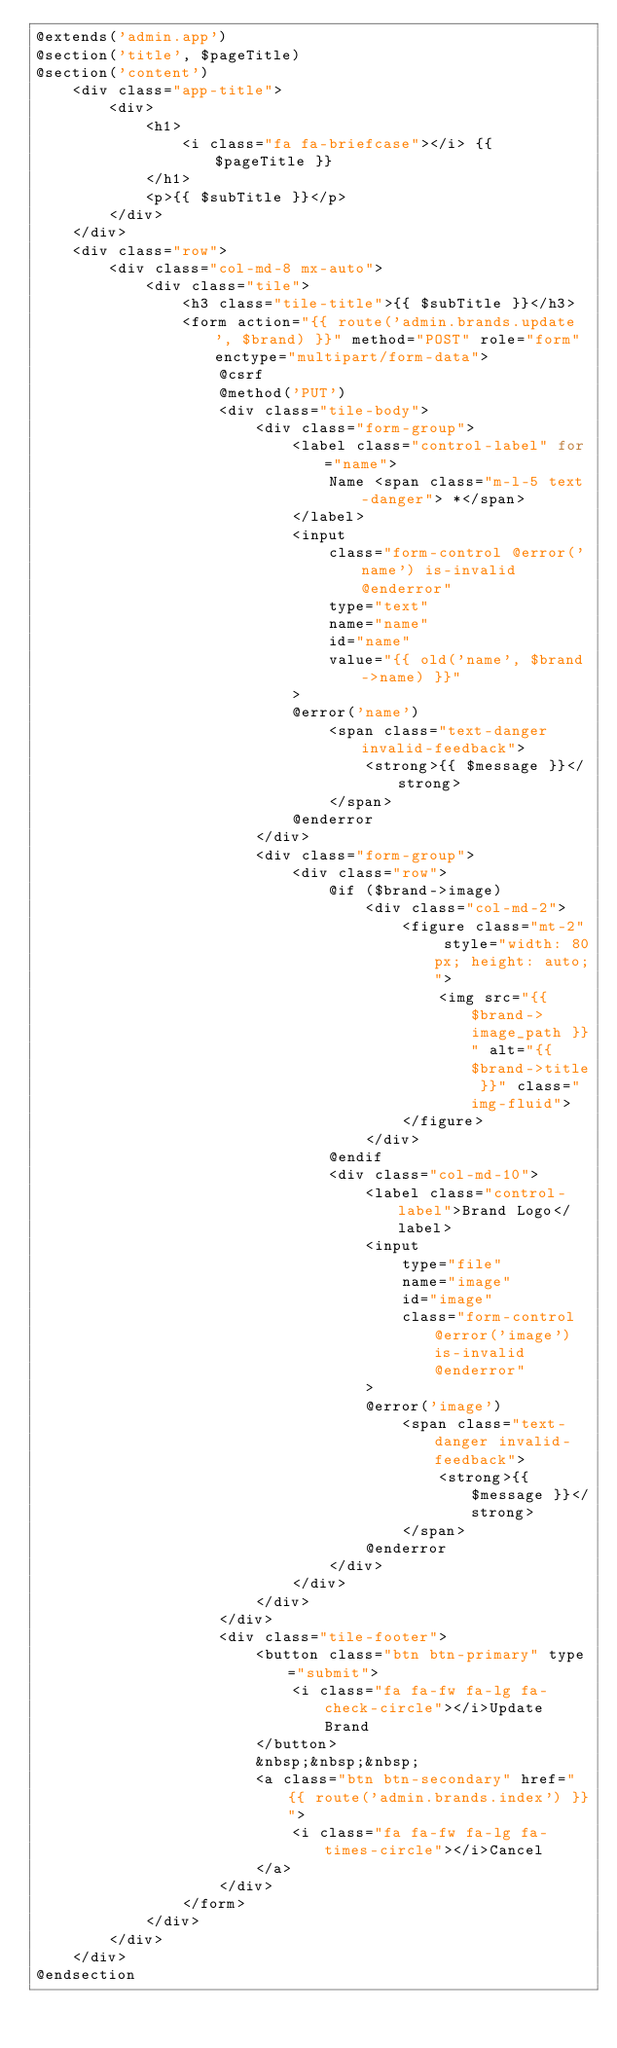<code> <loc_0><loc_0><loc_500><loc_500><_PHP_>@extends('admin.app')
@section('title', $pageTitle)
@section('content')
    <div class="app-title">
        <div>
            <h1>
                <i class="fa fa-briefcase"></i> {{ $pageTitle }}
            </h1>
            <p>{{ $subTitle }}</p>
        </div>
    </div>
    <div class="row">
        <div class="col-md-8 mx-auto">
            <div class="tile">
                <h3 class="tile-title">{{ $subTitle }}</h3>
                <form action="{{ route('admin.brands.update', $brand) }}" method="POST" role="form" enctype="multipart/form-data">
                    @csrf
                    @method('PUT')
                    <div class="tile-body">
                        <div class="form-group">
                            <label class="control-label" for="name">
                                Name <span class="m-l-5 text-danger"> *</span>
                            </label>
                            <input 
                                class="form-control @error('name') is-invalid @enderror" 
                                type="text" 
                                name="name" 
                                id="name" 
                                value="{{ old('name', $brand->name) }}"
                            >
                            @error('name')
                                <span class="text-danger invalid-feedback">
                                    <strong>{{ $message }}</strong>
                                </span>
                            @enderror
                        </div>
                        <div class="form-group">
                            <div class="row">
                                @if ($brand->image)
                                    <div class="col-md-2">
                                        <figure class="mt-2" style="width: 80px; height: auto;">
                                            <img src="{{ $brand->image_path }}" alt="{{ $brand->title }}" class="img-fluid">
                                        </figure>
                                    </div>
                                @endif
                                <div class="col-md-10">
                                    <label class="control-label">Brand Logo</label>
                                    <input 
                                        type="file" 
                                        name="image" 
                                        id="image" 
                                        class="form-control @error('image') is-invalid @enderror"
                                    >
                                    @error('image')
                                        <span class="text-danger invalid-feedback">
                                            <strong>{{ $message }}</strong>
                                        </span>
                                    @enderror
                                </div>
                            </div>
                        </div>
                    </div>
                    <div class="tile-footer">
                        <button class="btn btn-primary" type="submit">
                            <i class="fa fa-fw fa-lg fa-check-circle"></i>Update Brand
                        </button>
                        &nbsp;&nbsp;&nbsp;
                        <a class="btn btn-secondary" href="{{ route('admin.brands.index') }}">
                            <i class="fa fa-fw fa-lg fa-times-circle"></i>Cancel
                        </a>
                    </div>
                </form>
            </div>
        </div>
    </div>
@endsection</code> 